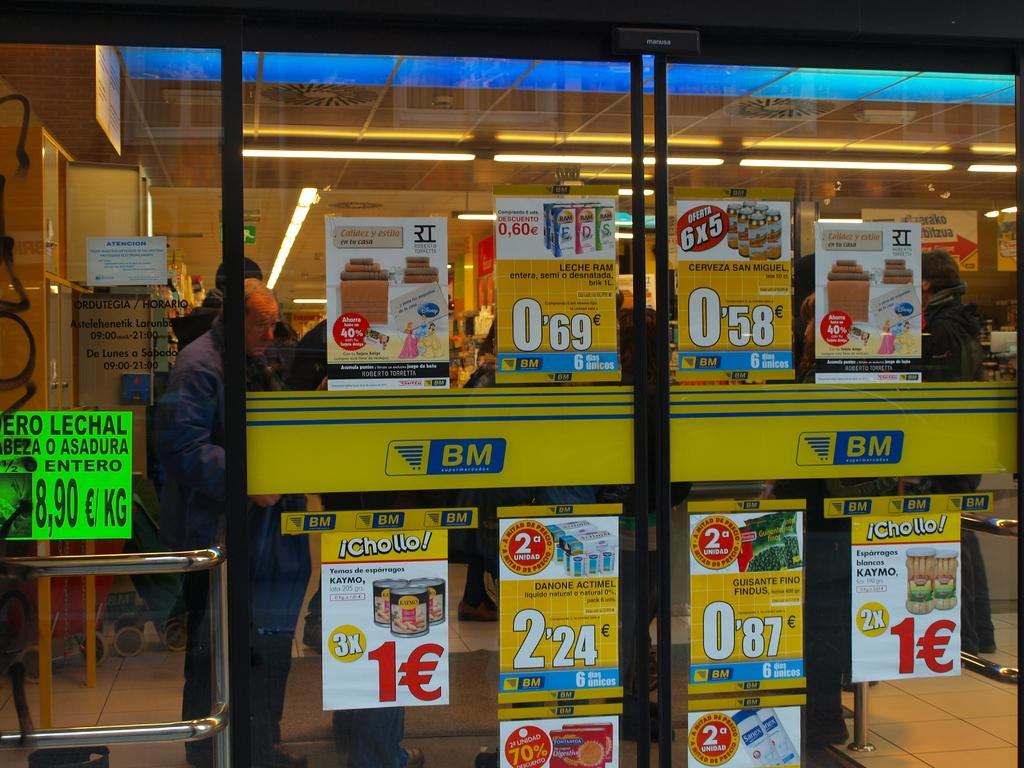<image>
Present a compact description of the photo's key features. a BM store front doors advertises the things that are on sale 